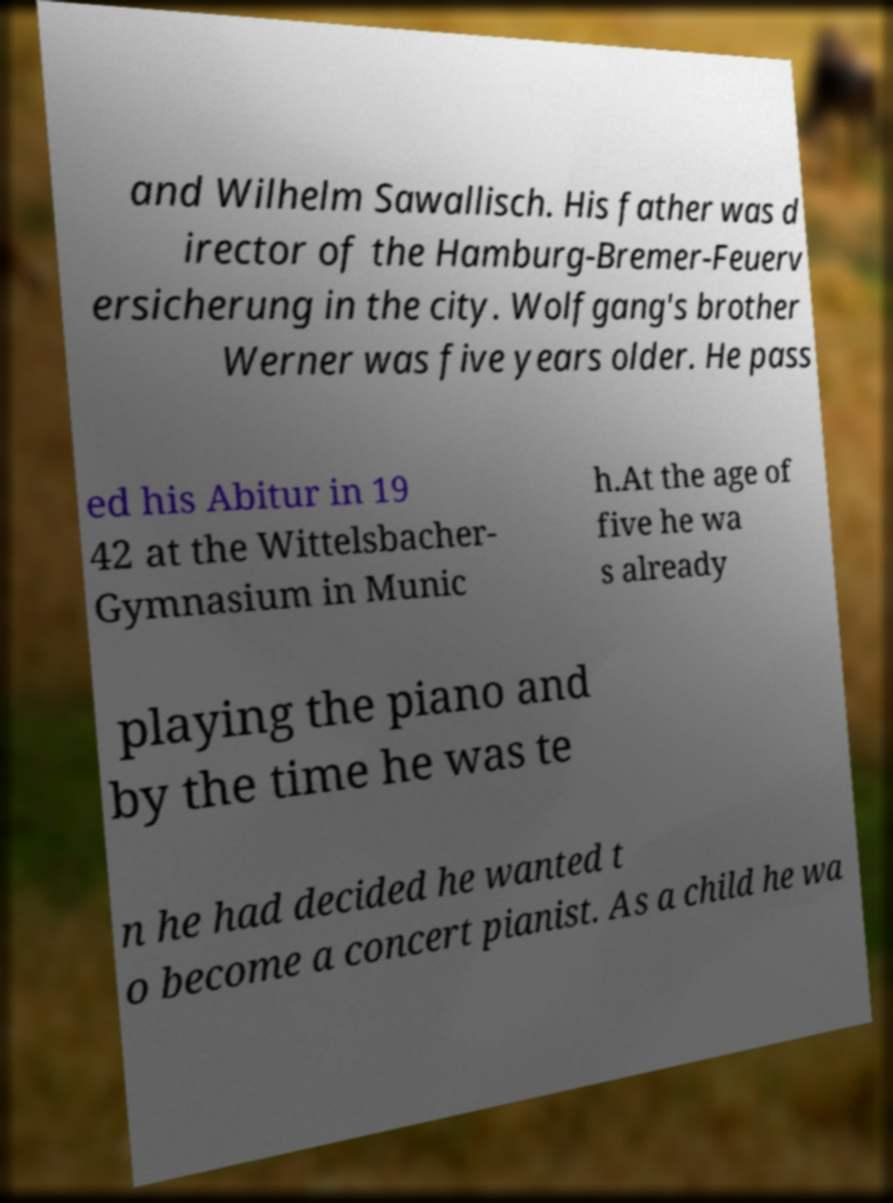There's text embedded in this image that I need extracted. Can you transcribe it verbatim? and Wilhelm Sawallisch. His father was d irector of the Hamburg-Bremer-Feuerv ersicherung in the city. Wolfgang's brother Werner was five years older. He pass ed his Abitur in 19 42 at the Wittelsbacher- Gymnasium in Munic h.At the age of five he wa s already playing the piano and by the time he was te n he had decided he wanted t o become a concert pianist. As a child he wa 